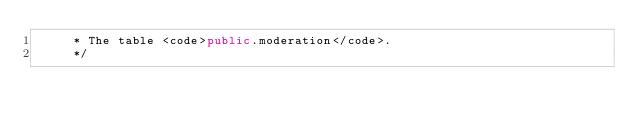Convert code to text. <code><loc_0><loc_0><loc_500><loc_500><_Java_>     * The table <code>public.moderation</code>.
     */</code> 